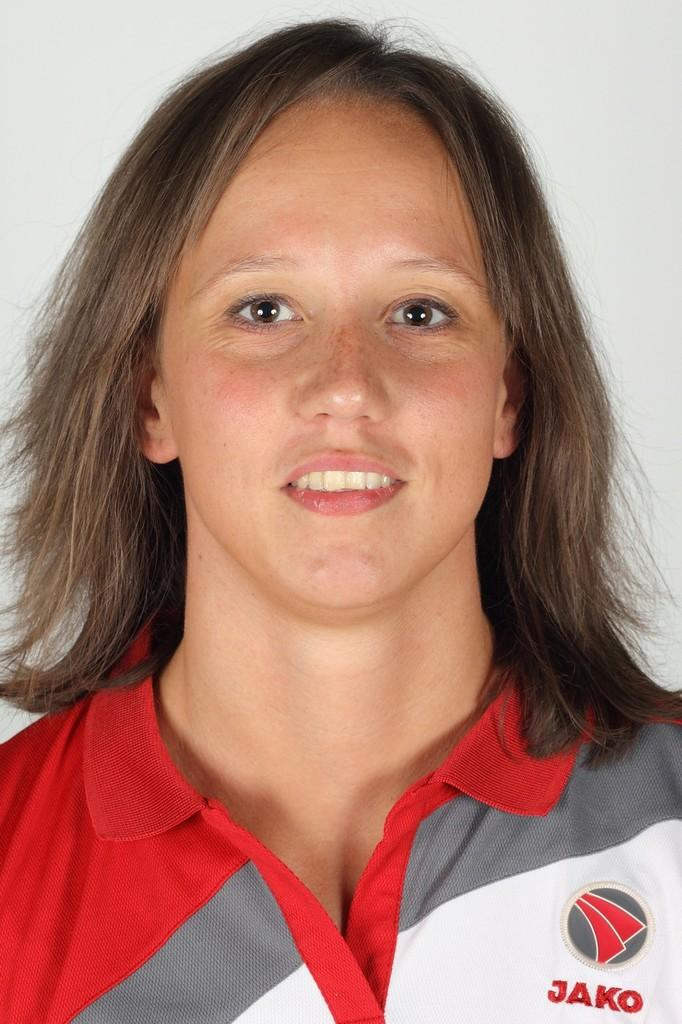<image>
Offer a succinct explanation of the picture presented. A woman wearing a red, grey and white shirt that say Jako. 